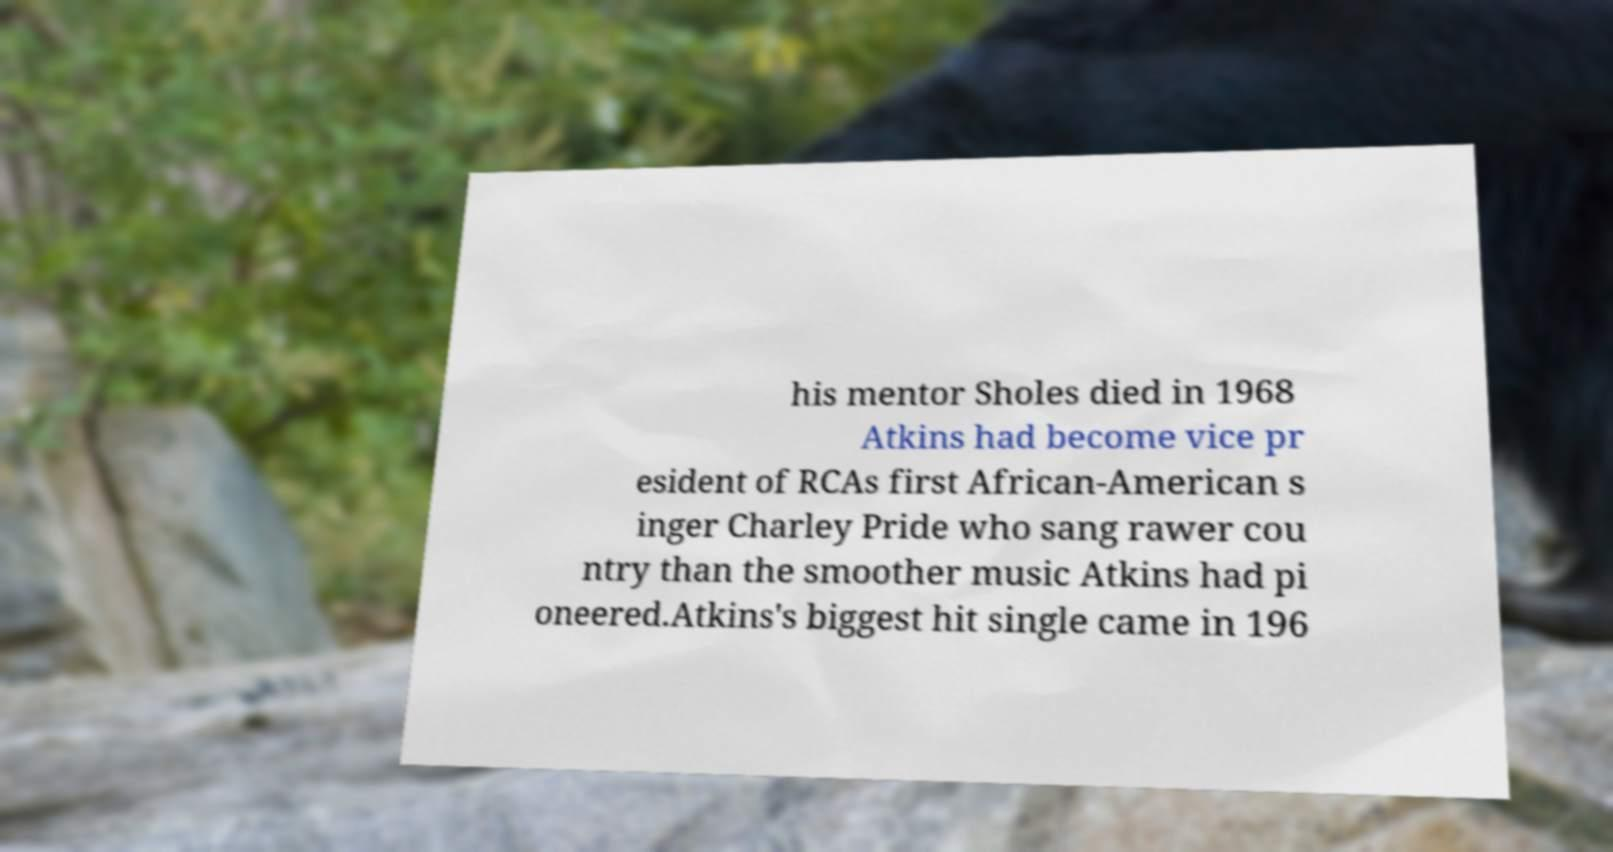I need the written content from this picture converted into text. Can you do that? his mentor Sholes died in 1968 Atkins had become vice pr esident of RCAs first African-American s inger Charley Pride who sang rawer cou ntry than the smoother music Atkins had pi oneered.Atkins's biggest hit single came in 196 